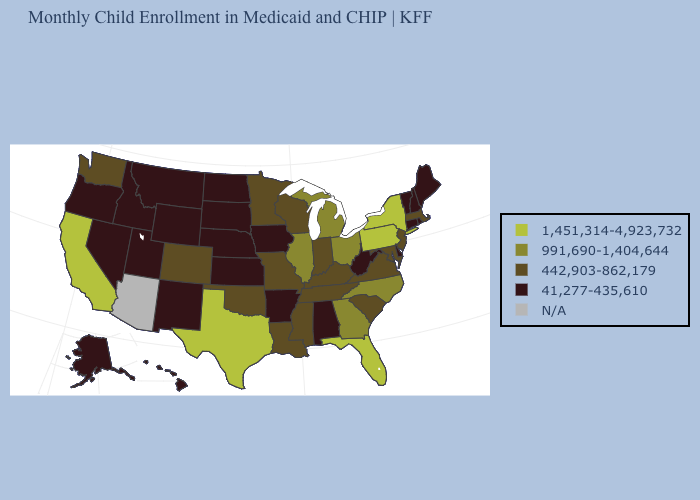What is the value of Idaho?
Be succinct. 41,277-435,610. Name the states that have a value in the range 41,277-435,610?
Give a very brief answer. Alabama, Alaska, Arkansas, Connecticut, Delaware, Hawaii, Idaho, Iowa, Kansas, Maine, Montana, Nebraska, Nevada, New Hampshire, New Mexico, North Dakota, Oregon, Rhode Island, South Dakota, Utah, Vermont, West Virginia, Wyoming. What is the value of Michigan?
Be succinct. 991,690-1,404,644. Does Colorado have the lowest value in the West?
Quick response, please. No. Which states have the lowest value in the Northeast?
Short answer required. Connecticut, Maine, New Hampshire, Rhode Island, Vermont. Name the states that have a value in the range N/A?
Give a very brief answer. Arizona. Name the states that have a value in the range N/A?
Concise answer only. Arizona. What is the value of Maine?
Short answer required. 41,277-435,610. Does Washington have the highest value in the West?
Quick response, please. No. What is the value of Texas?
Keep it brief. 1,451,314-4,923,732. What is the value of Colorado?
Answer briefly. 442,903-862,179. What is the value of New Mexico?
Answer briefly. 41,277-435,610. Does the first symbol in the legend represent the smallest category?
Write a very short answer. No. Among the states that border South Dakota , which have the highest value?
Answer briefly. Minnesota. 